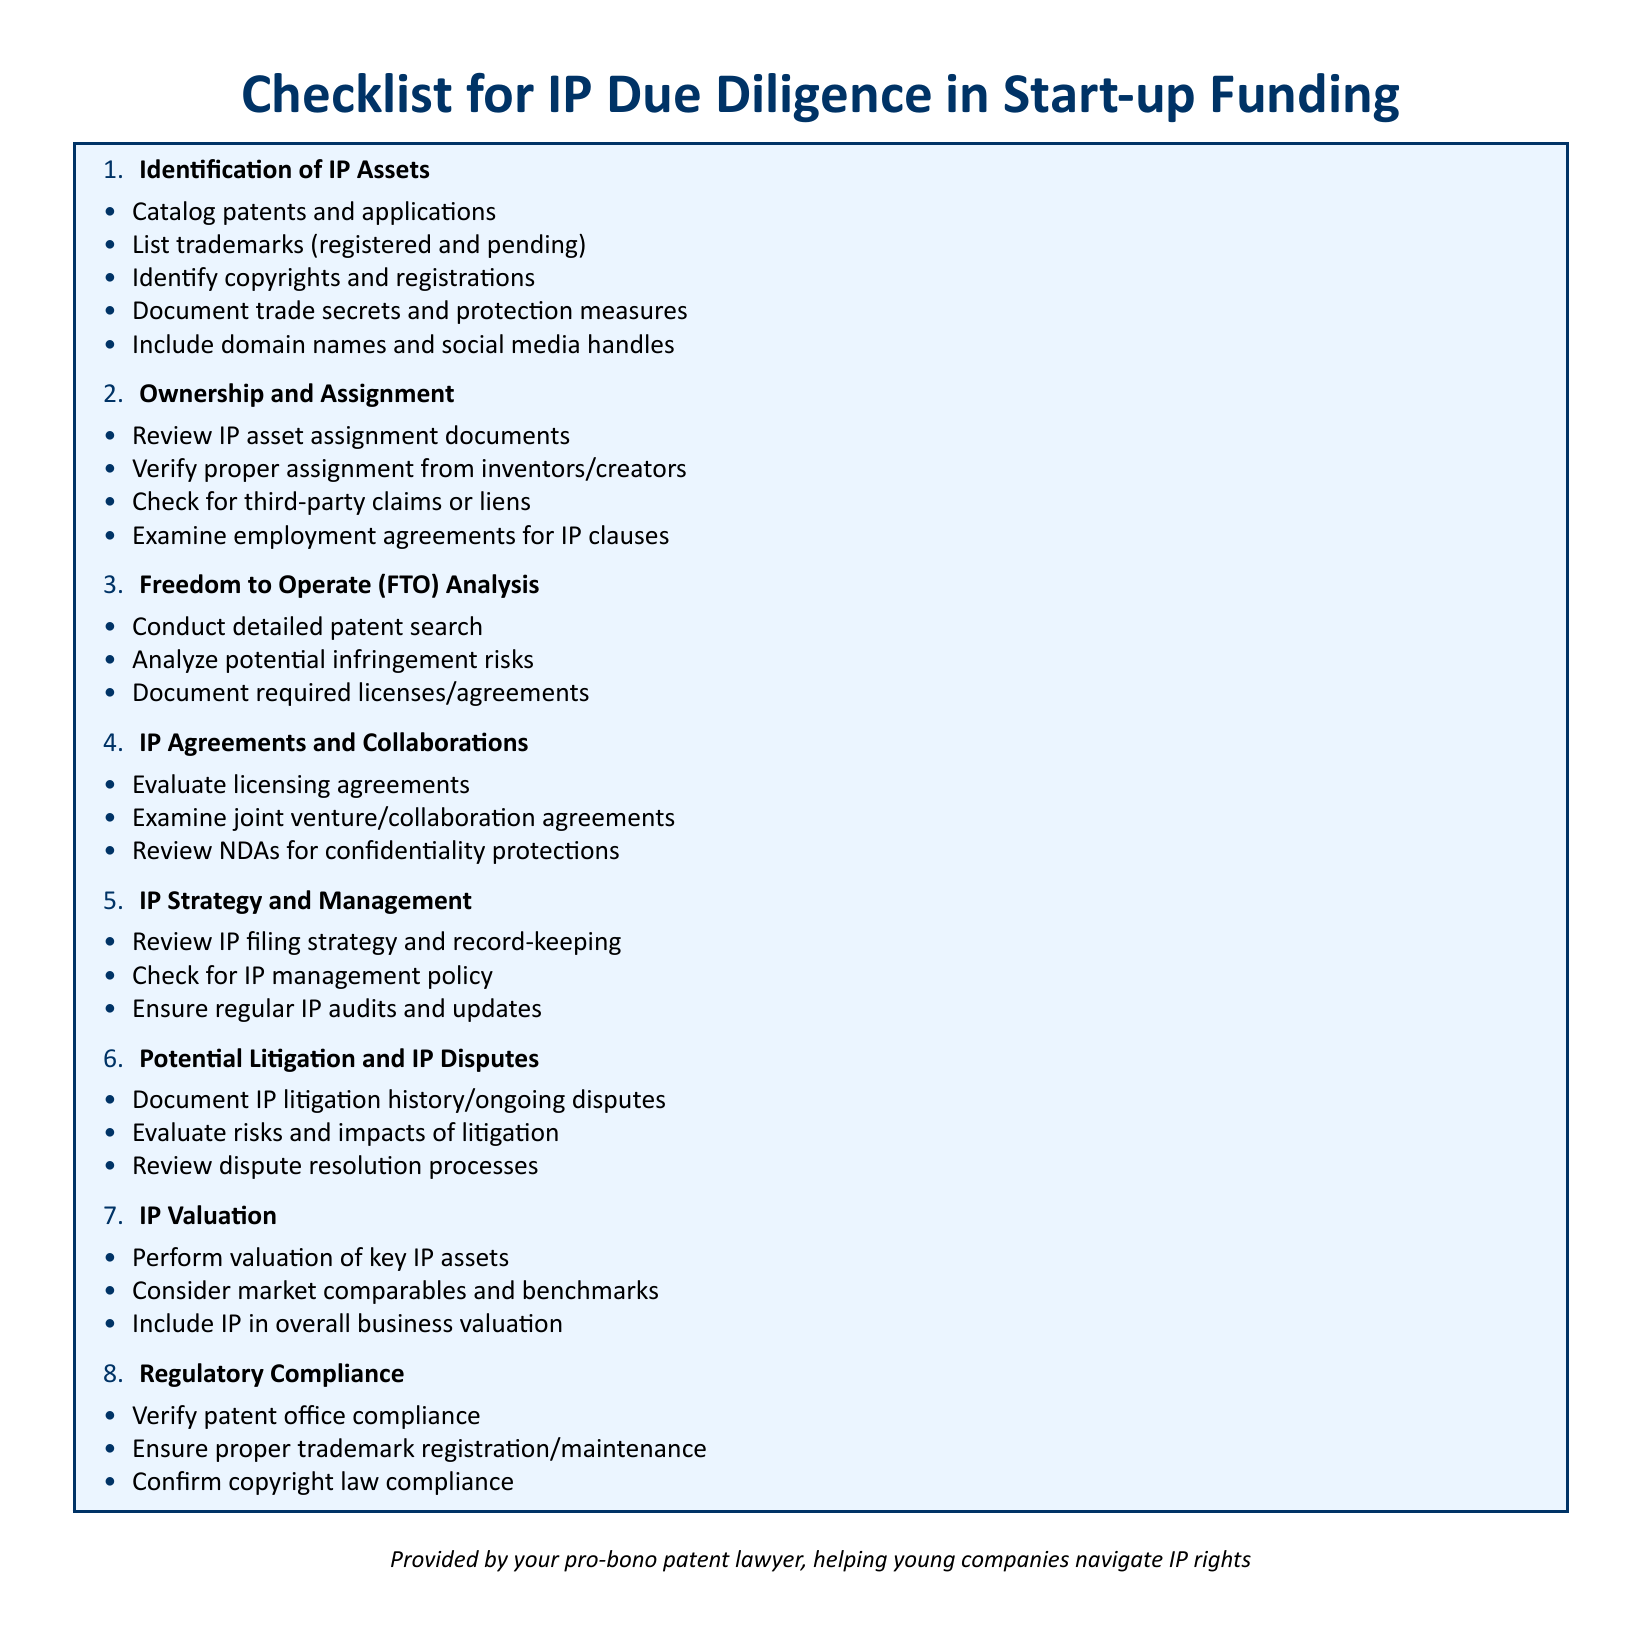What is the first item in the checklist? The first item in the checklist is "Identification of IP Assets."
Answer: Identification of IP Assets How many items are listed under "Ownership and Assignment"? There are four items listed under "Ownership and Assignment."
Answer: 4 What is the purpose of conducting a Freedom to Operate analysis? The purpose is to analyze potential infringement risks.
Answer: Analyze potential infringement risks What are the two key components evaluated under "IP Valuation"? The two key components are "perform valuation of key IP assets" and "consider market comparables and benchmarks."
Answer: perform valuation of key IP assets, consider market comparables and benchmarks What section follows "Potential Litigation and IP Disputes" in the checklist? The section that follows is "IP Valuation."
Answer: IP Valuation How many total sections are in the checklist? There are seven total sections in the checklist.
Answer: 7 What document type is this checklist designed for? This checklist is designed for IP due diligence in start-up funding.
Answer: IP due diligence in start-up funding What is included in the documentation of trade secrets? The protection measures are included in the documentation of trade secrets.
Answer: Protection measures 